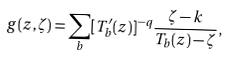Convert formula to latex. <formula><loc_0><loc_0><loc_500><loc_500>g ( z , \zeta ) = \sum _ { b } [ T _ { b } ^ { \prime } ( z ) ] ^ { - q } \frac { \zeta - k } { T _ { b } ( z ) - \zeta } ,</formula> 